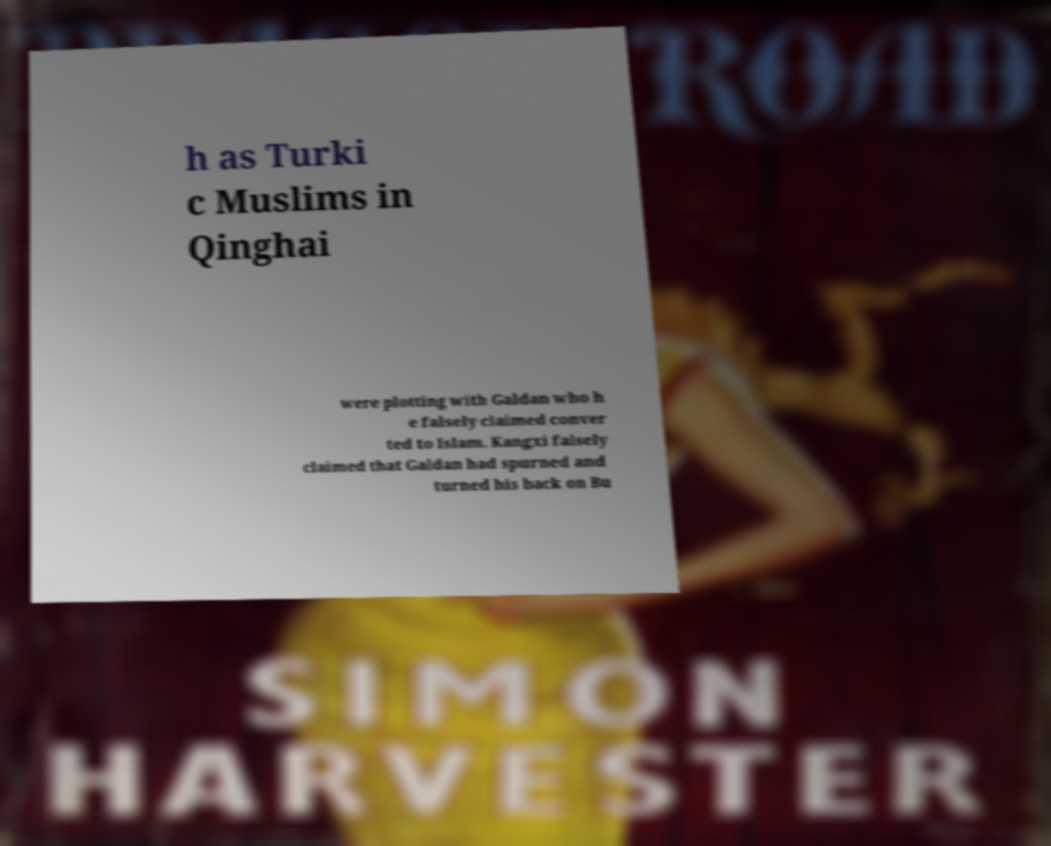Could you extract and type out the text from this image? h as Turki c Muslims in Qinghai were plotting with Galdan who h e falsely claimed conver ted to Islam. Kangxi falsely claimed that Galdan had spurned and turned his back on Bu 